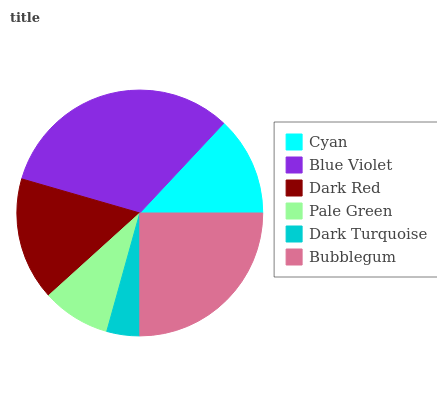Is Dark Turquoise the minimum?
Answer yes or no. Yes. Is Blue Violet the maximum?
Answer yes or no. Yes. Is Dark Red the minimum?
Answer yes or no. No. Is Dark Red the maximum?
Answer yes or no. No. Is Blue Violet greater than Dark Red?
Answer yes or no. Yes. Is Dark Red less than Blue Violet?
Answer yes or no. Yes. Is Dark Red greater than Blue Violet?
Answer yes or no. No. Is Blue Violet less than Dark Red?
Answer yes or no. No. Is Dark Red the high median?
Answer yes or no. Yes. Is Cyan the low median?
Answer yes or no. Yes. Is Bubblegum the high median?
Answer yes or no. No. Is Dark Red the low median?
Answer yes or no. No. 